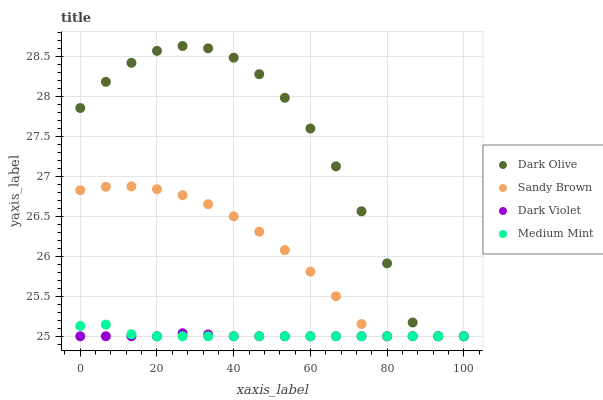Does Dark Violet have the minimum area under the curve?
Answer yes or no. Yes. Does Dark Olive have the maximum area under the curve?
Answer yes or no. Yes. Does Sandy Brown have the minimum area under the curve?
Answer yes or no. No. Does Sandy Brown have the maximum area under the curve?
Answer yes or no. No. Is Dark Violet the smoothest?
Answer yes or no. Yes. Is Dark Olive the roughest?
Answer yes or no. Yes. Is Sandy Brown the smoothest?
Answer yes or no. No. Is Sandy Brown the roughest?
Answer yes or no. No. Does Medium Mint have the lowest value?
Answer yes or no. Yes. Does Dark Olive have the highest value?
Answer yes or no. Yes. Does Sandy Brown have the highest value?
Answer yes or no. No. Does Dark Olive intersect Medium Mint?
Answer yes or no. Yes. Is Dark Olive less than Medium Mint?
Answer yes or no. No. Is Dark Olive greater than Medium Mint?
Answer yes or no. No. 